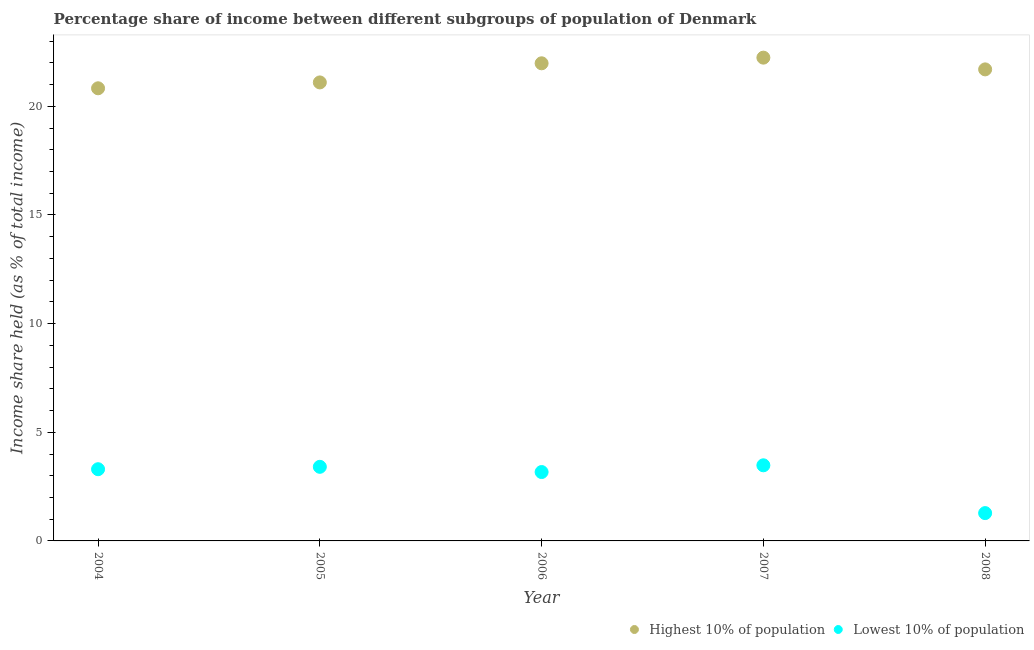What is the income share held by highest 10% of the population in 2008?
Give a very brief answer. 21.7. Across all years, what is the maximum income share held by lowest 10% of the population?
Offer a very short reply. 3.48. Across all years, what is the minimum income share held by highest 10% of the population?
Keep it short and to the point. 20.83. In which year was the income share held by lowest 10% of the population maximum?
Your answer should be compact. 2007. What is the total income share held by lowest 10% of the population in the graph?
Make the answer very short. 14.64. What is the difference between the income share held by highest 10% of the population in 2005 and that in 2006?
Give a very brief answer. -0.88. What is the difference between the income share held by lowest 10% of the population in 2007 and the income share held by highest 10% of the population in 2008?
Offer a very short reply. -18.22. What is the average income share held by lowest 10% of the population per year?
Give a very brief answer. 2.93. In the year 2008, what is the difference between the income share held by highest 10% of the population and income share held by lowest 10% of the population?
Your response must be concise. 20.42. What is the ratio of the income share held by highest 10% of the population in 2006 to that in 2007?
Offer a terse response. 0.99. Is the difference between the income share held by lowest 10% of the population in 2004 and 2007 greater than the difference between the income share held by highest 10% of the population in 2004 and 2007?
Give a very brief answer. Yes. What is the difference between the highest and the second highest income share held by lowest 10% of the population?
Your answer should be very brief. 0.07. What is the difference between the highest and the lowest income share held by lowest 10% of the population?
Provide a succinct answer. 2.2. Does the income share held by highest 10% of the population monotonically increase over the years?
Your answer should be very brief. No. How many dotlines are there?
Offer a terse response. 2. Are the values on the major ticks of Y-axis written in scientific E-notation?
Give a very brief answer. No. What is the title of the graph?
Your response must be concise. Percentage share of income between different subgroups of population of Denmark. Does "Diesel" appear as one of the legend labels in the graph?
Your response must be concise. No. What is the label or title of the X-axis?
Make the answer very short. Year. What is the label or title of the Y-axis?
Give a very brief answer. Income share held (as % of total income). What is the Income share held (as % of total income) of Highest 10% of population in 2004?
Make the answer very short. 20.83. What is the Income share held (as % of total income) of Highest 10% of population in 2005?
Your answer should be very brief. 21.1. What is the Income share held (as % of total income) of Lowest 10% of population in 2005?
Give a very brief answer. 3.41. What is the Income share held (as % of total income) in Highest 10% of population in 2006?
Provide a short and direct response. 21.98. What is the Income share held (as % of total income) in Lowest 10% of population in 2006?
Ensure brevity in your answer.  3.17. What is the Income share held (as % of total income) in Highest 10% of population in 2007?
Offer a very short reply. 22.24. What is the Income share held (as % of total income) of Lowest 10% of population in 2007?
Offer a terse response. 3.48. What is the Income share held (as % of total income) in Highest 10% of population in 2008?
Your answer should be very brief. 21.7. What is the Income share held (as % of total income) of Lowest 10% of population in 2008?
Offer a very short reply. 1.28. Across all years, what is the maximum Income share held (as % of total income) in Highest 10% of population?
Give a very brief answer. 22.24. Across all years, what is the maximum Income share held (as % of total income) of Lowest 10% of population?
Offer a very short reply. 3.48. Across all years, what is the minimum Income share held (as % of total income) in Highest 10% of population?
Your response must be concise. 20.83. Across all years, what is the minimum Income share held (as % of total income) in Lowest 10% of population?
Offer a very short reply. 1.28. What is the total Income share held (as % of total income) of Highest 10% of population in the graph?
Offer a terse response. 107.85. What is the total Income share held (as % of total income) in Lowest 10% of population in the graph?
Provide a succinct answer. 14.64. What is the difference between the Income share held (as % of total income) of Highest 10% of population in 2004 and that in 2005?
Give a very brief answer. -0.27. What is the difference between the Income share held (as % of total income) in Lowest 10% of population in 2004 and that in 2005?
Keep it short and to the point. -0.11. What is the difference between the Income share held (as % of total income) of Highest 10% of population in 2004 and that in 2006?
Ensure brevity in your answer.  -1.15. What is the difference between the Income share held (as % of total income) of Lowest 10% of population in 2004 and that in 2006?
Offer a very short reply. 0.13. What is the difference between the Income share held (as % of total income) in Highest 10% of population in 2004 and that in 2007?
Ensure brevity in your answer.  -1.41. What is the difference between the Income share held (as % of total income) in Lowest 10% of population in 2004 and that in 2007?
Make the answer very short. -0.18. What is the difference between the Income share held (as % of total income) of Highest 10% of population in 2004 and that in 2008?
Ensure brevity in your answer.  -0.87. What is the difference between the Income share held (as % of total income) of Lowest 10% of population in 2004 and that in 2008?
Your response must be concise. 2.02. What is the difference between the Income share held (as % of total income) in Highest 10% of population in 2005 and that in 2006?
Provide a short and direct response. -0.88. What is the difference between the Income share held (as % of total income) of Lowest 10% of population in 2005 and that in 2006?
Make the answer very short. 0.24. What is the difference between the Income share held (as % of total income) in Highest 10% of population in 2005 and that in 2007?
Make the answer very short. -1.14. What is the difference between the Income share held (as % of total income) of Lowest 10% of population in 2005 and that in 2007?
Provide a succinct answer. -0.07. What is the difference between the Income share held (as % of total income) of Highest 10% of population in 2005 and that in 2008?
Give a very brief answer. -0.6. What is the difference between the Income share held (as % of total income) of Lowest 10% of population in 2005 and that in 2008?
Your response must be concise. 2.13. What is the difference between the Income share held (as % of total income) of Highest 10% of population in 2006 and that in 2007?
Provide a succinct answer. -0.26. What is the difference between the Income share held (as % of total income) of Lowest 10% of population in 2006 and that in 2007?
Ensure brevity in your answer.  -0.31. What is the difference between the Income share held (as % of total income) in Highest 10% of population in 2006 and that in 2008?
Keep it short and to the point. 0.28. What is the difference between the Income share held (as % of total income) of Lowest 10% of population in 2006 and that in 2008?
Your answer should be compact. 1.89. What is the difference between the Income share held (as % of total income) in Highest 10% of population in 2007 and that in 2008?
Offer a very short reply. 0.54. What is the difference between the Income share held (as % of total income) of Lowest 10% of population in 2007 and that in 2008?
Offer a terse response. 2.2. What is the difference between the Income share held (as % of total income) in Highest 10% of population in 2004 and the Income share held (as % of total income) in Lowest 10% of population in 2005?
Make the answer very short. 17.42. What is the difference between the Income share held (as % of total income) in Highest 10% of population in 2004 and the Income share held (as % of total income) in Lowest 10% of population in 2006?
Offer a terse response. 17.66. What is the difference between the Income share held (as % of total income) in Highest 10% of population in 2004 and the Income share held (as % of total income) in Lowest 10% of population in 2007?
Offer a terse response. 17.35. What is the difference between the Income share held (as % of total income) of Highest 10% of population in 2004 and the Income share held (as % of total income) of Lowest 10% of population in 2008?
Ensure brevity in your answer.  19.55. What is the difference between the Income share held (as % of total income) of Highest 10% of population in 2005 and the Income share held (as % of total income) of Lowest 10% of population in 2006?
Your answer should be compact. 17.93. What is the difference between the Income share held (as % of total income) of Highest 10% of population in 2005 and the Income share held (as % of total income) of Lowest 10% of population in 2007?
Offer a very short reply. 17.62. What is the difference between the Income share held (as % of total income) in Highest 10% of population in 2005 and the Income share held (as % of total income) in Lowest 10% of population in 2008?
Your answer should be compact. 19.82. What is the difference between the Income share held (as % of total income) of Highest 10% of population in 2006 and the Income share held (as % of total income) of Lowest 10% of population in 2007?
Make the answer very short. 18.5. What is the difference between the Income share held (as % of total income) of Highest 10% of population in 2006 and the Income share held (as % of total income) of Lowest 10% of population in 2008?
Offer a very short reply. 20.7. What is the difference between the Income share held (as % of total income) in Highest 10% of population in 2007 and the Income share held (as % of total income) in Lowest 10% of population in 2008?
Your response must be concise. 20.96. What is the average Income share held (as % of total income) in Highest 10% of population per year?
Offer a terse response. 21.57. What is the average Income share held (as % of total income) in Lowest 10% of population per year?
Offer a very short reply. 2.93. In the year 2004, what is the difference between the Income share held (as % of total income) in Highest 10% of population and Income share held (as % of total income) in Lowest 10% of population?
Make the answer very short. 17.53. In the year 2005, what is the difference between the Income share held (as % of total income) in Highest 10% of population and Income share held (as % of total income) in Lowest 10% of population?
Your answer should be compact. 17.69. In the year 2006, what is the difference between the Income share held (as % of total income) in Highest 10% of population and Income share held (as % of total income) in Lowest 10% of population?
Ensure brevity in your answer.  18.81. In the year 2007, what is the difference between the Income share held (as % of total income) of Highest 10% of population and Income share held (as % of total income) of Lowest 10% of population?
Provide a short and direct response. 18.76. In the year 2008, what is the difference between the Income share held (as % of total income) in Highest 10% of population and Income share held (as % of total income) in Lowest 10% of population?
Ensure brevity in your answer.  20.42. What is the ratio of the Income share held (as % of total income) of Highest 10% of population in 2004 to that in 2005?
Ensure brevity in your answer.  0.99. What is the ratio of the Income share held (as % of total income) of Lowest 10% of population in 2004 to that in 2005?
Your answer should be very brief. 0.97. What is the ratio of the Income share held (as % of total income) in Highest 10% of population in 2004 to that in 2006?
Ensure brevity in your answer.  0.95. What is the ratio of the Income share held (as % of total income) in Lowest 10% of population in 2004 to that in 2006?
Provide a succinct answer. 1.04. What is the ratio of the Income share held (as % of total income) of Highest 10% of population in 2004 to that in 2007?
Give a very brief answer. 0.94. What is the ratio of the Income share held (as % of total income) in Lowest 10% of population in 2004 to that in 2007?
Keep it short and to the point. 0.95. What is the ratio of the Income share held (as % of total income) of Highest 10% of population in 2004 to that in 2008?
Your response must be concise. 0.96. What is the ratio of the Income share held (as % of total income) of Lowest 10% of population in 2004 to that in 2008?
Your answer should be very brief. 2.58. What is the ratio of the Income share held (as % of total income) of Lowest 10% of population in 2005 to that in 2006?
Your response must be concise. 1.08. What is the ratio of the Income share held (as % of total income) of Highest 10% of population in 2005 to that in 2007?
Offer a very short reply. 0.95. What is the ratio of the Income share held (as % of total income) of Lowest 10% of population in 2005 to that in 2007?
Ensure brevity in your answer.  0.98. What is the ratio of the Income share held (as % of total income) in Highest 10% of population in 2005 to that in 2008?
Provide a short and direct response. 0.97. What is the ratio of the Income share held (as % of total income) of Lowest 10% of population in 2005 to that in 2008?
Give a very brief answer. 2.66. What is the ratio of the Income share held (as % of total income) of Highest 10% of population in 2006 to that in 2007?
Your answer should be compact. 0.99. What is the ratio of the Income share held (as % of total income) of Lowest 10% of population in 2006 to that in 2007?
Offer a terse response. 0.91. What is the ratio of the Income share held (as % of total income) in Highest 10% of population in 2006 to that in 2008?
Your answer should be compact. 1.01. What is the ratio of the Income share held (as % of total income) in Lowest 10% of population in 2006 to that in 2008?
Provide a short and direct response. 2.48. What is the ratio of the Income share held (as % of total income) in Highest 10% of population in 2007 to that in 2008?
Keep it short and to the point. 1.02. What is the ratio of the Income share held (as % of total income) in Lowest 10% of population in 2007 to that in 2008?
Your answer should be very brief. 2.72. What is the difference between the highest and the second highest Income share held (as % of total income) of Highest 10% of population?
Offer a very short reply. 0.26. What is the difference between the highest and the second highest Income share held (as % of total income) of Lowest 10% of population?
Provide a short and direct response. 0.07. What is the difference between the highest and the lowest Income share held (as % of total income) in Highest 10% of population?
Provide a succinct answer. 1.41. What is the difference between the highest and the lowest Income share held (as % of total income) of Lowest 10% of population?
Provide a short and direct response. 2.2. 